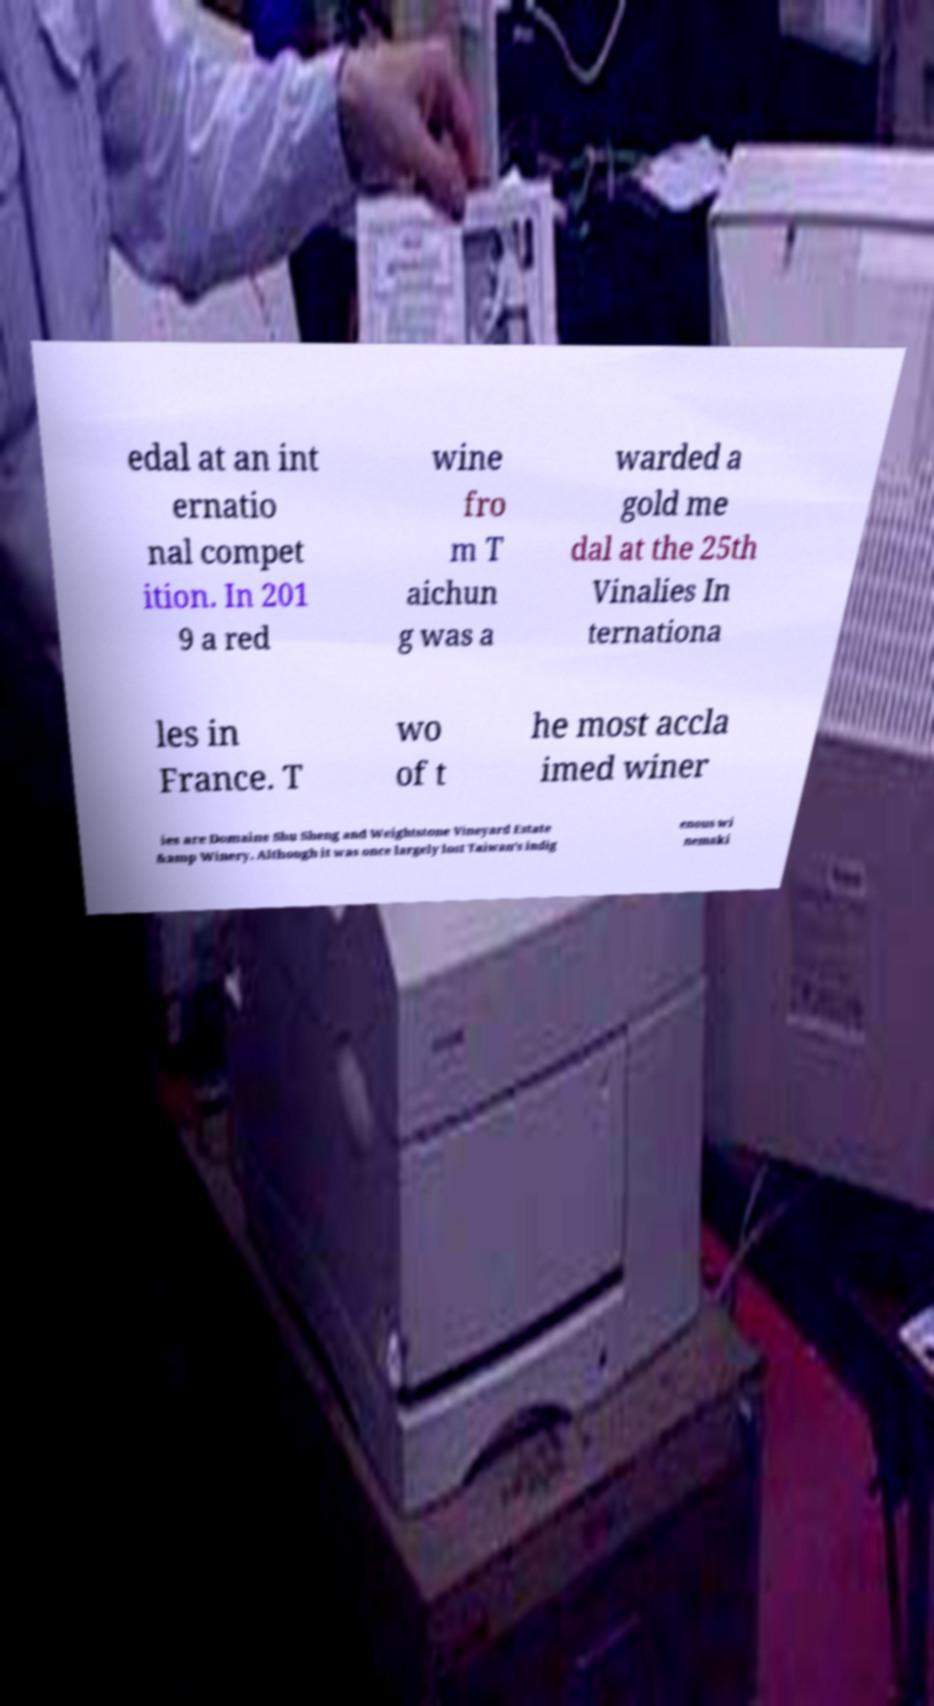Please read and relay the text visible in this image. What does it say? edal at an int ernatio nal compet ition. In 201 9 a red wine fro m T aichun g was a warded a gold me dal at the 25th Vinalies In ternationa les in France. T wo of t he most accla imed winer ies are Domaine Shu Sheng and Weightstone Vineyard Estate &amp Winery. Although it was once largely lost Taiwan's indig enous wi nemaki 